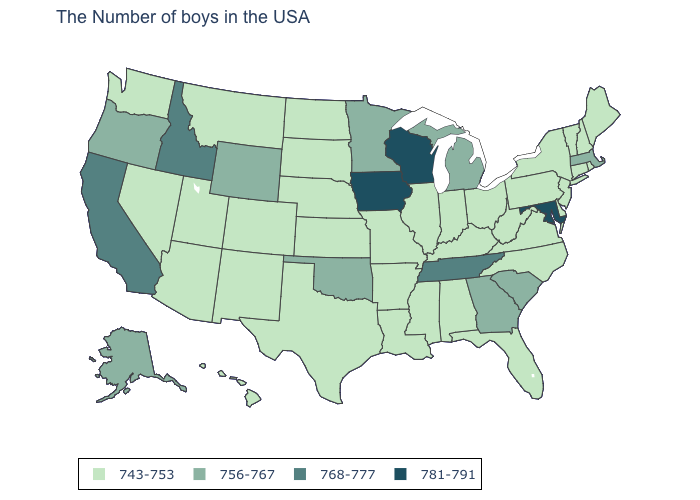What is the value of Iowa?
Quick response, please. 781-791. Does Maryland have the highest value in the USA?
Write a very short answer. Yes. What is the value of Arizona?
Answer briefly. 743-753. Among the states that border Nevada , which have the lowest value?
Quick response, please. Utah, Arizona. Does West Virginia have the highest value in the South?
Be succinct. No. Does Maine have a lower value than Vermont?
Keep it brief. No. Does the map have missing data?
Give a very brief answer. No. Name the states that have a value in the range 768-777?
Keep it brief. Tennessee, Idaho, California. Which states hav the highest value in the South?
Write a very short answer. Maryland. What is the highest value in the South ?
Keep it brief. 781-791. What is the lowest value in the Northeast?
Quick response, please. 743-753. Among the states that border West Virginia , does Virginia have the highest value?
Write a very short answer. No. Name the states that have a value in the range 743-753?
Give a very brief answer. Maine, Rhode Island, New Hampshire, Vermont, Connecticut, New York, New Jersey, Delaware, Pennsylvania, Virginia, North Carolina, West Virginia, Ohio, Florida, Kentucky, Indiana, Alabama, Illinois, Mississippi, Louisiana, Missouri, Arkansas, Kansas, Nebraska, Texas, South Dakota, North Dakota, Colorado, New Mexico, Utah, Montana, Arizona, Nevada, Washington, Hawaii. Does Rhode Island have the highest value in the Northeast?
Answer briefly. No. Does Maryland have the highest value in the South?
Keep it brief. Yes. 